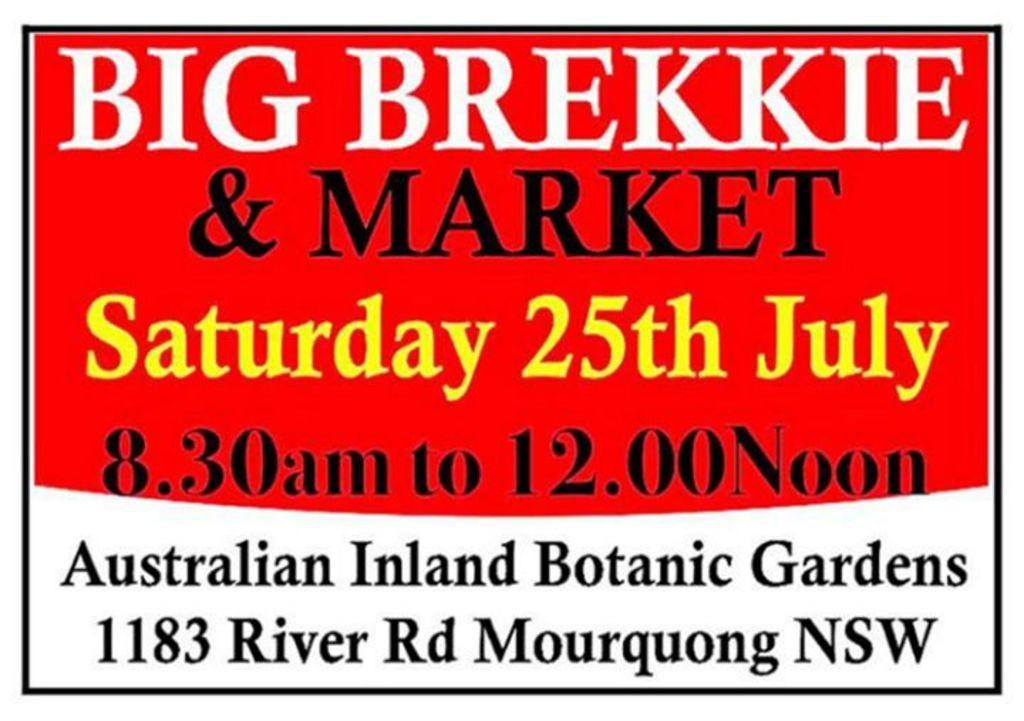What is the address of this market?
Your response must be concise. 1183 river rd mourquong nsw. What month is on the sign?
Provide a short and direct response. July. 